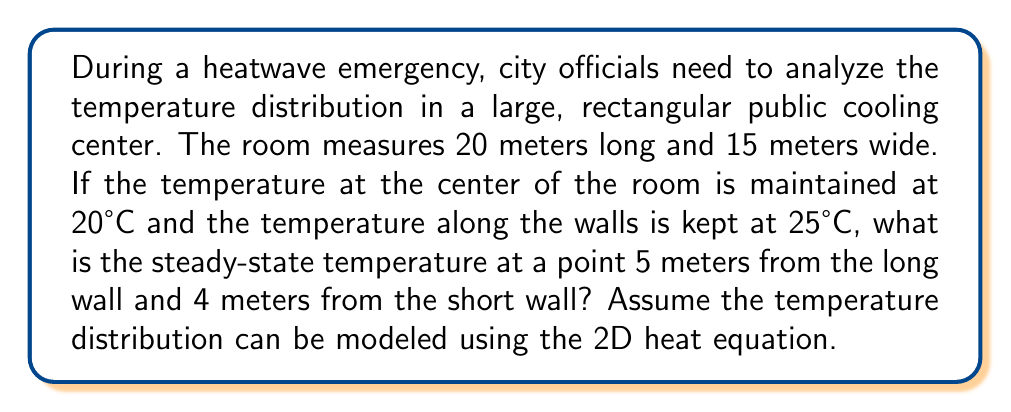What is the answer to this math problem? To solve this problem, we'll use the 2D steady-state heat equation and apply the given boundary conditions. The steps are as follows:

1) The 2D steady-state heat equation is:

   $$\frac{\partial^2 T}{\partial x^2} + \frac{\partial^2 T}{\partial y^2} = 0$$

2) Given the boundary conditions and the symmetry of the problem, we can use the solution:

   $$T(x,y) = T_c + (T_w - T_c) \frac{\cosh(\pi x/L) + \cosh(\pi y/W)}{\cosh(\pi a/2L) + \cosh(\pi b/2W)}$$

   Where:
   $T_c$ = temperature at the center (20°C)
   $T_w$ = temperature at the walls (25°C)
   $L$ = length of the room (20 m)
   $W$ = width of the room (15 m)
   $a$ = distance from center to point of interest along length (5 m)
   $b$ = distance from center to point of interest along width (7.5 m)

3) Substituting the values:

   $$T(5,7.5) = 20 + (25 - 20) \frac{\cosh(\pi 5/20) + \cosh(\pi 7.5/15)}{\cosh(\pi 10/20) + \cosh(\pi 7.5/15)}$$

4) Simplifying:

   $$T(5,7.5) = 20 + 5 \frac{\cosh(0.7854) + \cosh(1.5708)}{\cosh(1.5708) + \cosh(1.5708)}$$

5) Calculating:

   $$T(5,7.5) = 20 + 5 \frac{1.3104 + 2.5092}{2.5092 + 2.5092}$$
   $$T(5,7.5) = 20 + 5 \frac{3.8196}{5.0184}$$
   $$T(5,7.5) = 20 + 3.8052$$
   $$T(5,7.5) = 23.8052°C$$

6) Rounding to two decimal places:

   $$T(5,7.5) \approx 23.81°C$$
Answer: 23.81°C 